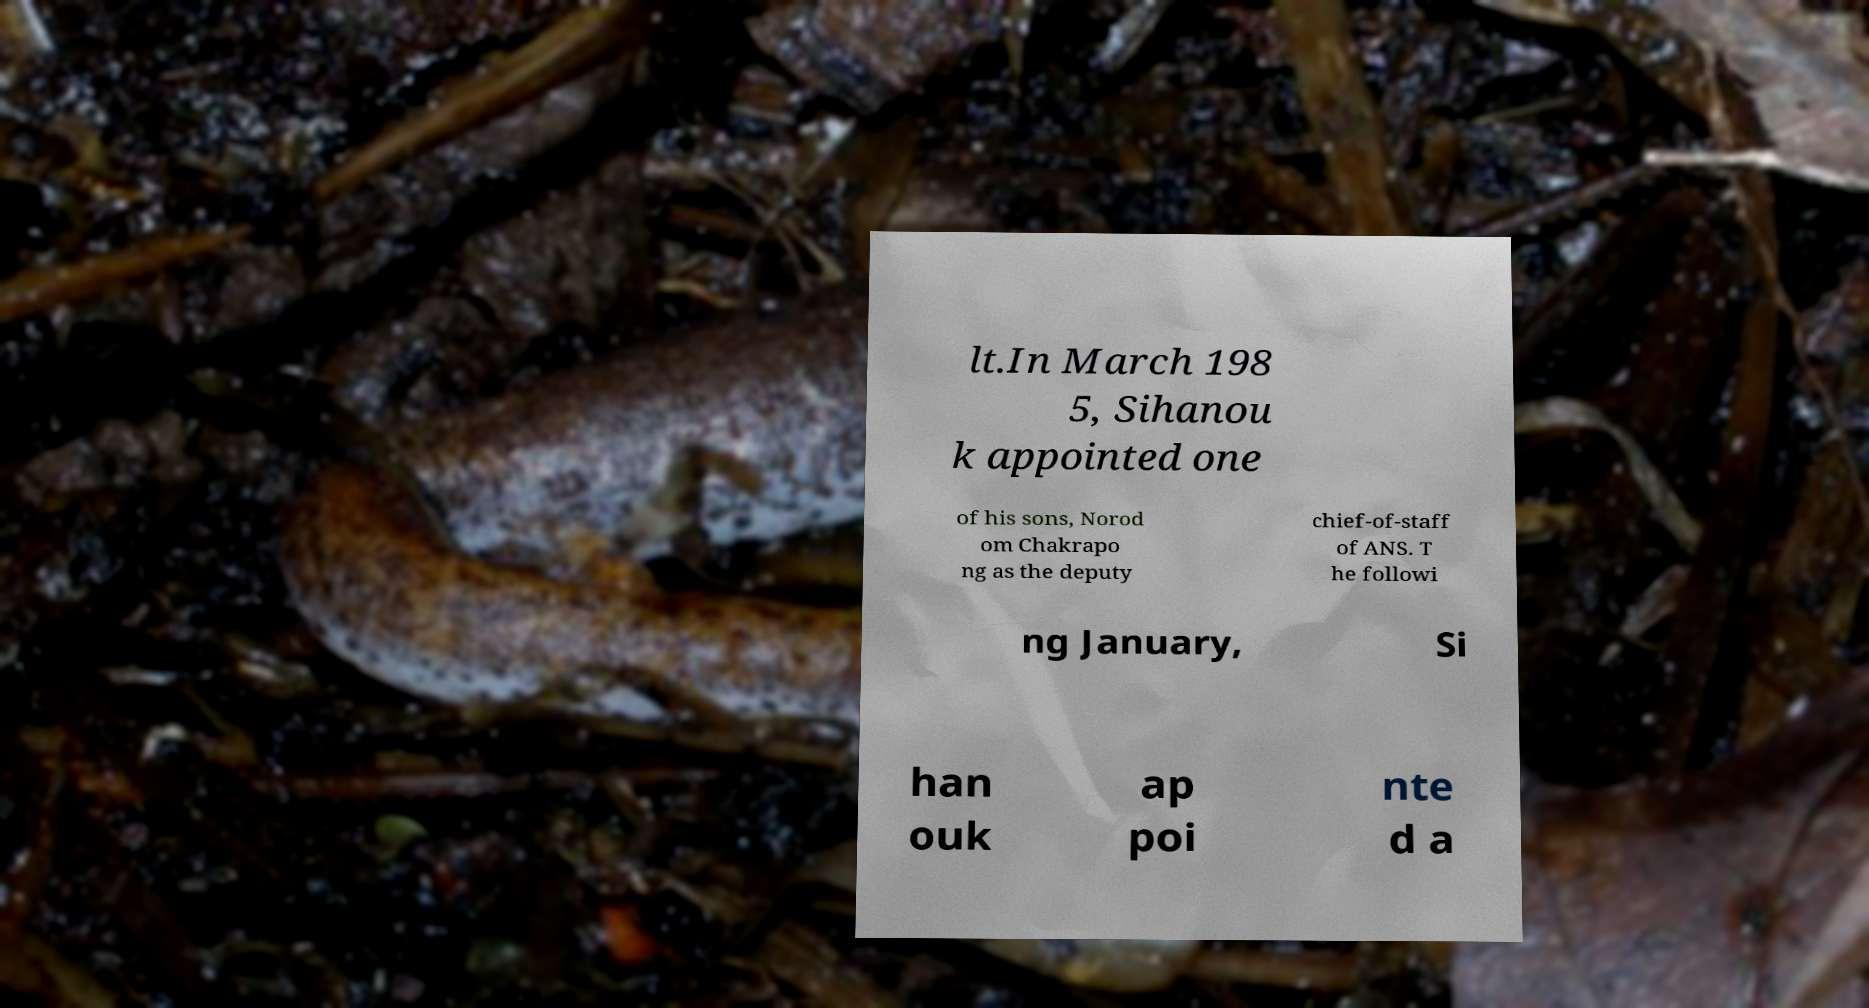Please identify and transcribe the text found in this image. lt.In March 198 5, Sihanou k appointed one of his sons, Norod om Chakrapo ng as the deputy chief-of-staff of ANS. T he followi ng January, Si han ouk ap poi nte d a 